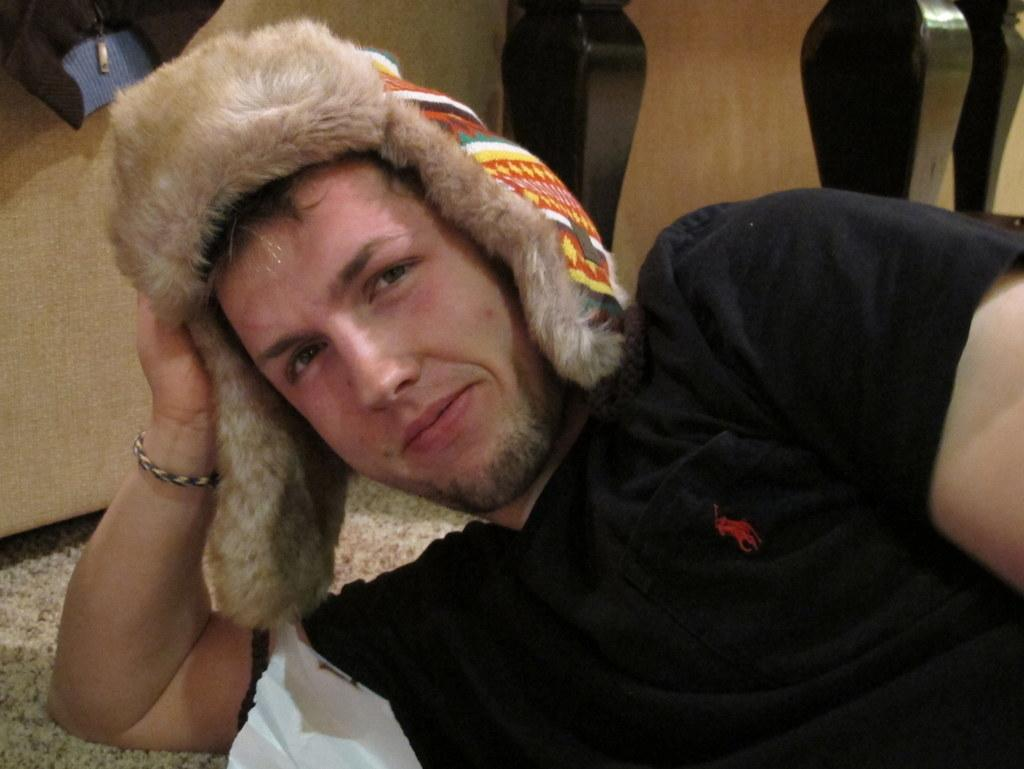Who is the main subject in the image? There is a man in the center of the image. What is the man wearing on his head? The man is wearing a cap. What is the man's position in the image? The man is lying down. What can be seen in the background of the image? There is a cot in the background of the image. What type of sign can be seen in the image? There is no sign present in the image; it features a man lying down with a cap on his head and a cot in the background. 